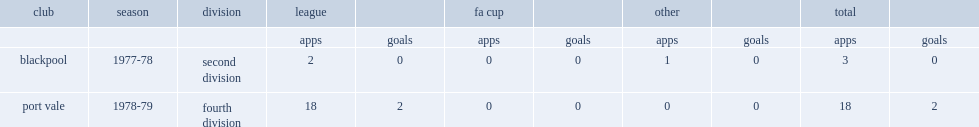How many appearances did sinclair make second division appearances for blackpool in the 1977-78 season? 2.0. 